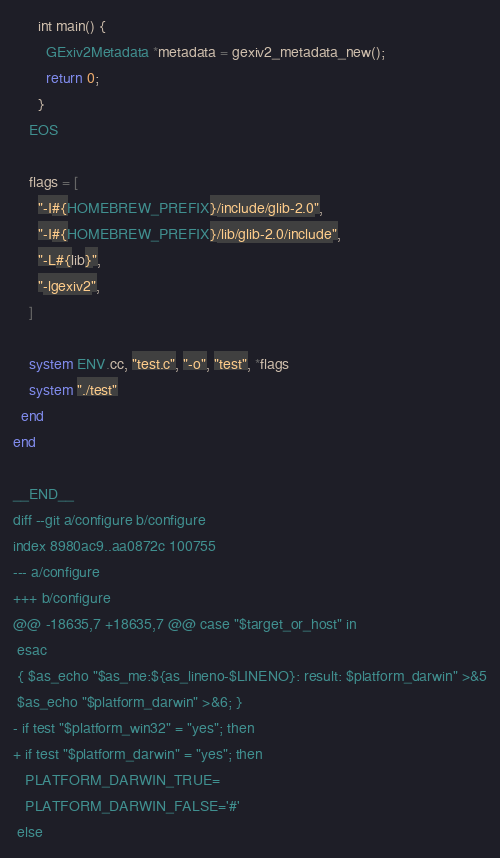<code> <loc_0><loc_0><loc_500><loc_500><_Ruby_>      int main() {
        GExiv2Metadata *metadata = gexiv2_metadata_new();
        return 0;
      }
    EOS

    flags = [
      "-I#{HOMEBREW_PREFIX}/include/glib-2.0",
      "-I#{HOMEBREW_PREFIX}/lib/glib-2.0/include",
      "-L#{lib}",
      "-lgexiv2",
    ]

    system ENV.cc, "test.c", "-o", "test", *flags
    system "./test"
  end
end

__END__
diff --git a/configure b/configure
index 8980ac9..aa0872c 100755
--- a/configure
+++ b/configure
@@ -18635,7 +18635,7 @@ case "$target_or_host" in
 esac
 { $as_echo "$as_me:${as_lineno-$LINENO}: result: $platform_darwin" >&5
 $as_echo "$platform_darwin" >&6; }
- if test "$platform_win32" = "yes"; then
+ if test "$platform_darwin" = "yes"; then
   PLATFORM_DARWIN_TRUE=
   PLATFORM_DARWIN_FALSE='#'
 else

</code> 